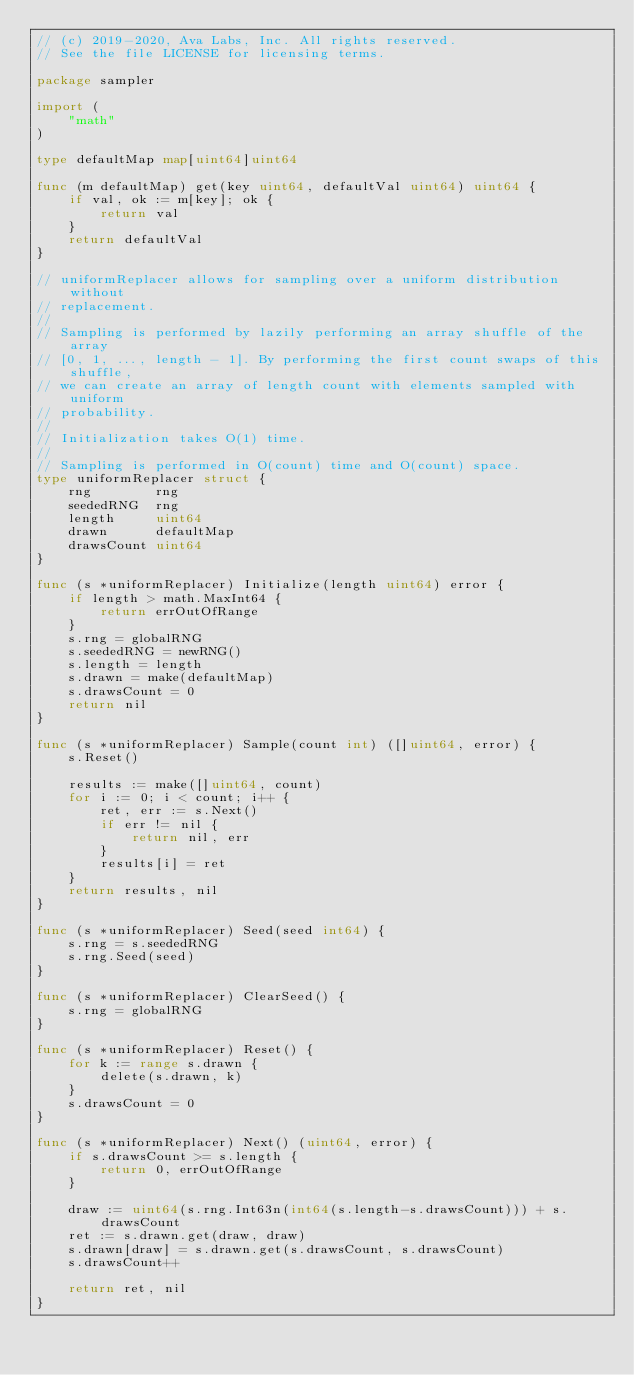Convert code to text. <code><loc_0><loc_0><loc_500><loc_500><_Go_>// (c) 2019-2020, Ava Labs, Inc. All rights reserved.
// See the file LICENSE for licensing terms.

package sampler

import (
	"math"
)

type defaultMap map[uint64]uint64

func (m defaultMap) get(key uint64, defaultVal uint64) uint64 {
	if val, ok := m[key]; ok {
		return val
	}
	return defaultVal
}

// uniformReplacer allows for sampling over a uniform distribution without
// replacement.
//
// Sampling is performed by lazily performing an array shuffle of the array
// [0, 1, ..., length - 1]. By performing the first count swaps of this shuffle,
// we can create an array of length count with elements sampled with uniform
// probability.
//
// Initialization takes O(1) time.
//
// Sampling is performed in O(count) time and O(count) space.
type uniformReplacer struct {
	rng        rng
	seededRNG  rng
	length     uint64
	drawn      defaultMap
	drawsCount uint64
}

func (s *uniformReplacer) Initialize(length uint64) error {
	if length > math.MaxInt64 {
		return errOutOfRange
	}
	s.rng = globalRNG
	s.seededRNG = newRNG()
	s.length = length
	s.drawn = make(defaultMap)
	s.drawsCount = 0
	return nil
}

func (s *uniformReplacer) Sample(count int) ([]uint64, error) {
	s.Reset()

	results := make([]uint64, count)
	for i := 0; i < count; i++ {
		ret, err := s.Next()
		if err != nil {
			return nil, err
		}
		results[i] = ret
	}
	return results, nil
}

func (s *uniformReplacer) Seed(seed int64) {
	s.rng = s.seededRNG
	s.rng.Seed(seed)
}

func (s *uniformReplacer) ClearSeed() {
	s.rng = globalRNG
}

func (s *uniformReplacer) Reset() {
	for k := range s.drawn {
		delete(s.drawn, k)
	}
	s.drawsCount = 0
}

func (s *uniformReplacer) Next() (uint64, error) {
	if s.drawsCount >= s.length {
		return 0, errOutOfRange
	}

	draw := uint64(s.rng.Int63n(int64(s.length-s.drawsCount))) + s.drawsCount
	ret := s.drawn.get(draw, draw)
	s.drawn[draw] = s.drawn.get(s.drawsCount, s.drawsCount)
	s.drawsCount++

	return ret, nil
}
</code> 